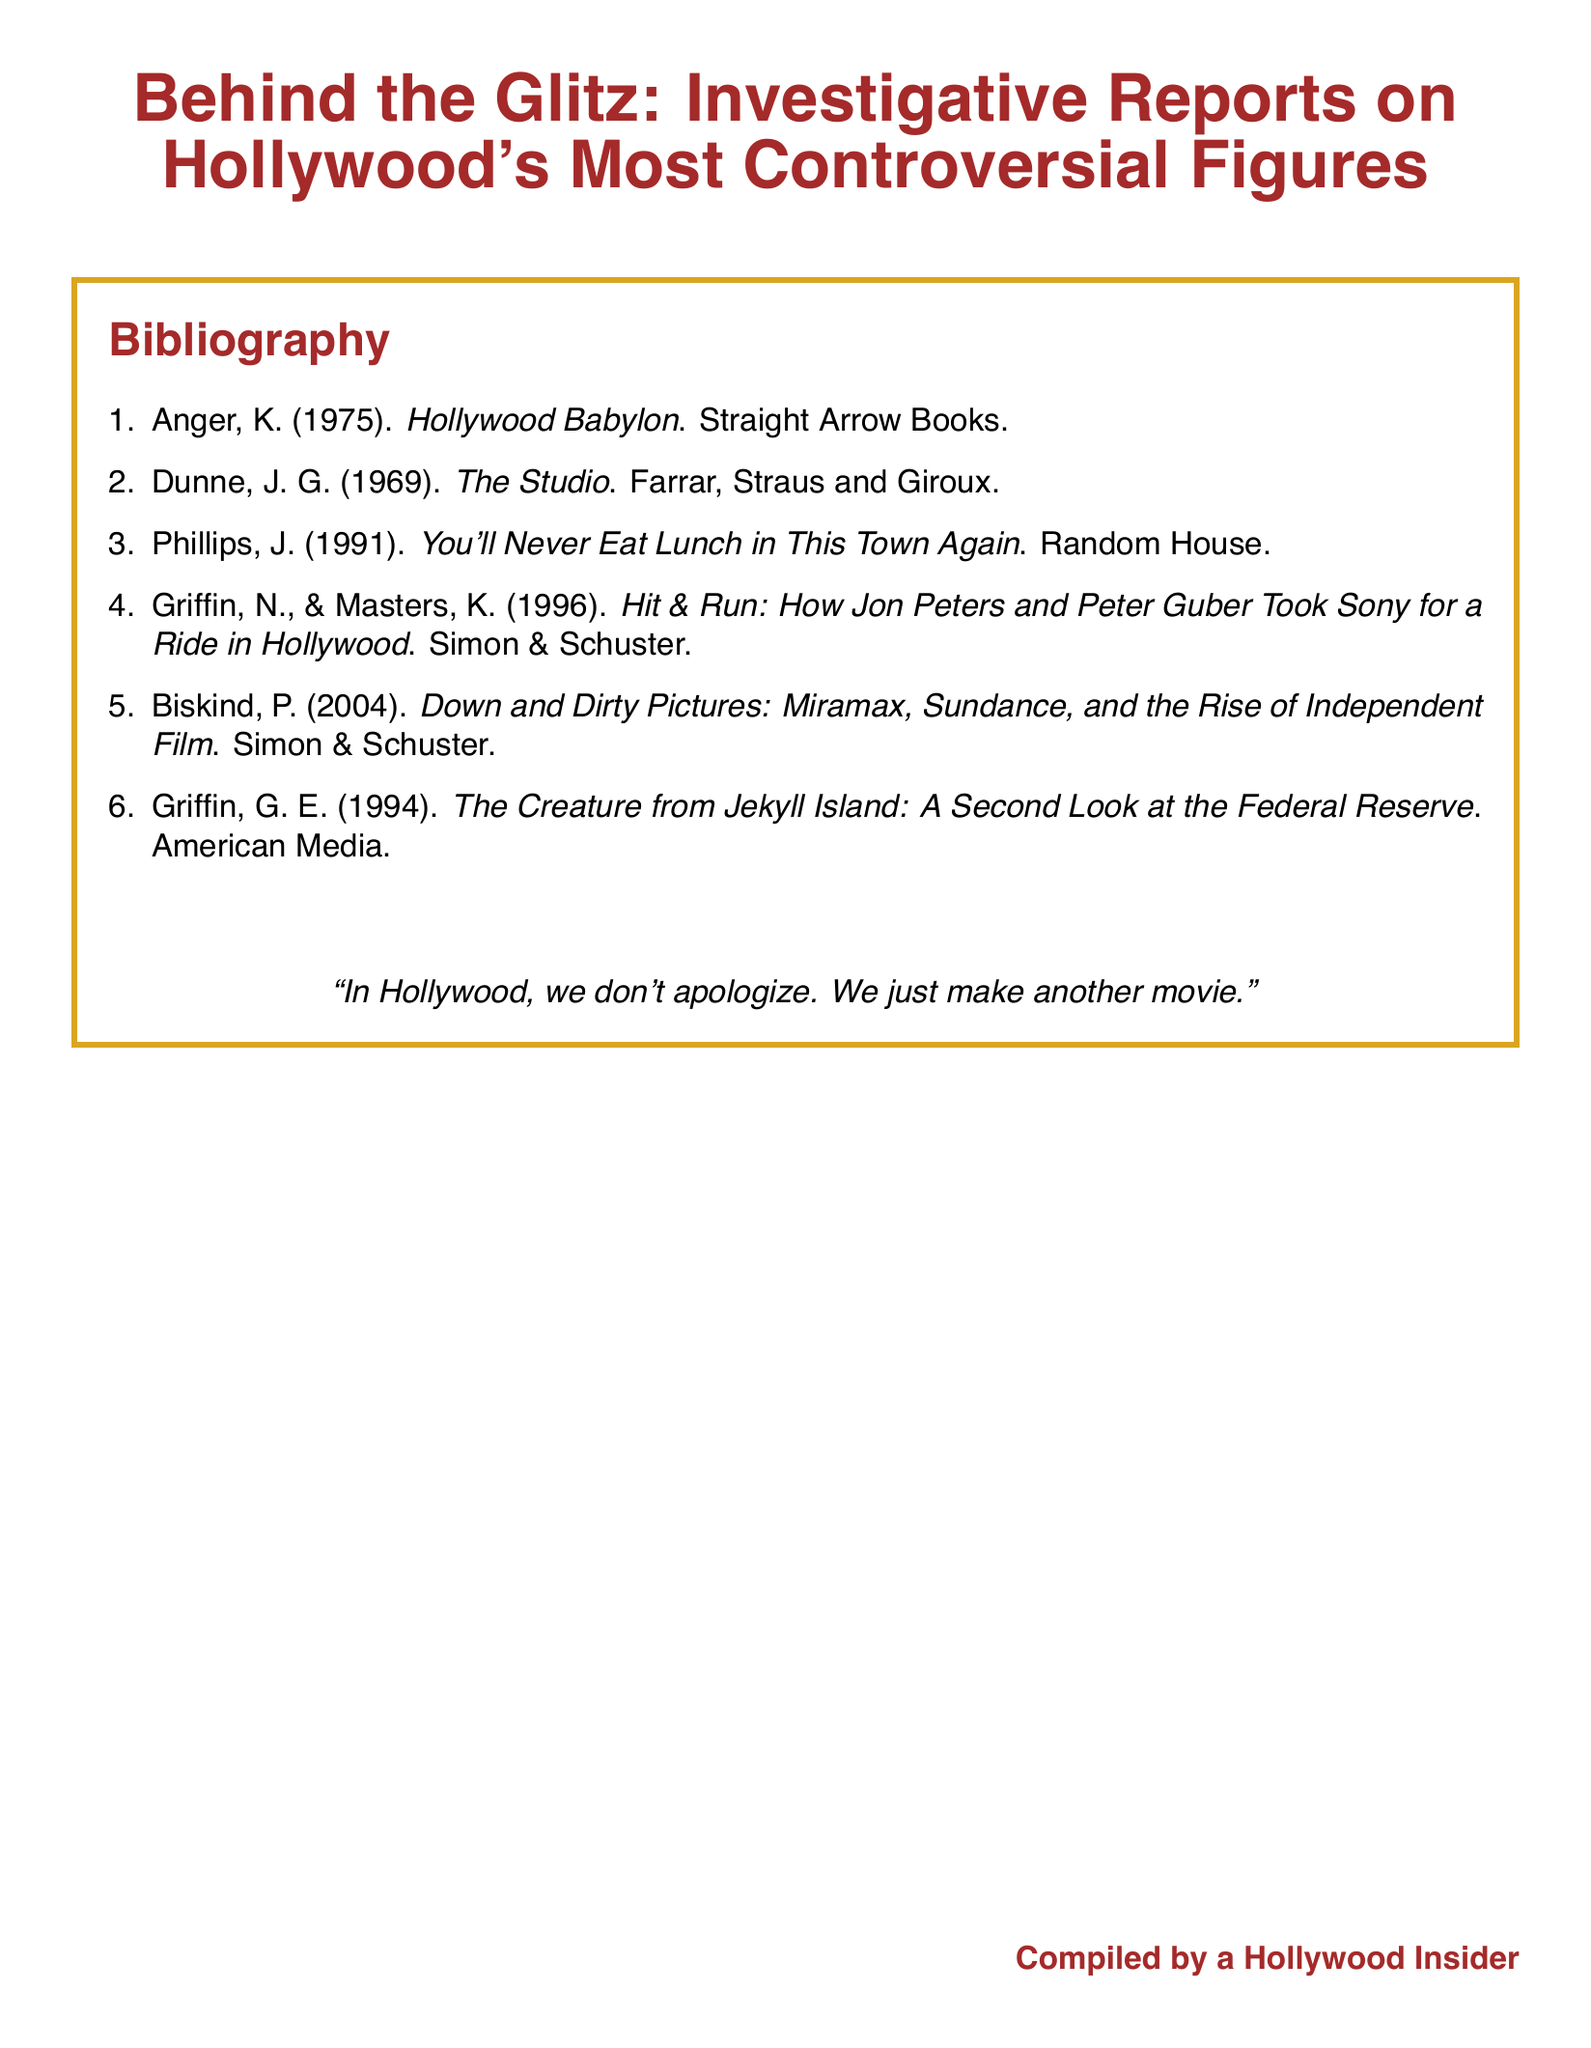what is the title of the document? The title is stated prominently at the top of the document as the main header.
Answer: Behind the Glitz: Investigative Reports on Hollywood's Most Controversial Figures how many books are listed in the bibliography? The number of entries in the bibliography corresponds to the count in the enumerated list.
Answer: 6 who is the author of "Hollywood Babylon"? The author is mentioned directly next to the title in the bibliography.
Answer: K. Anger what year was "You'll Never Eat Lunch in This Town Again" published? The year of publication is noted next to the author's name in the bibliography.
Answer: 1991 which publisher released "Down and Dirty Pictures"? The publisher's name is provided alongside the title in the bibliography.
Answer: Simon & Schuster what is the color theme of the document? The theme can be inferred by examining the colors used for the title and border throughout the document.
Answer: Red and gold 